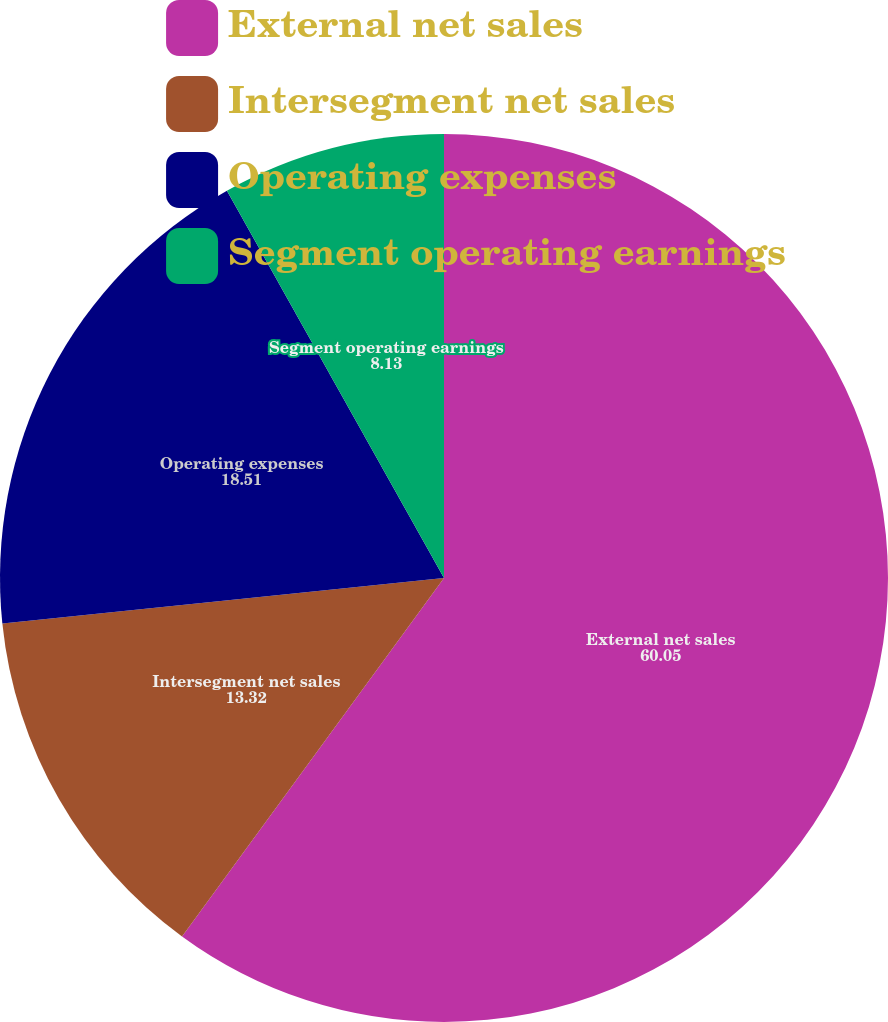Convert chart. <chart><loc_0><loc_0><loc_500><loc_500><pie_chart><fcel>External net sales<fcel>Intersegment net sales<fcel>Operating expenses<fcel>Segment operating earnings<nl><fcel>60.05%<fcel>13.32%<fcel>18.51%<fcel>8.13%<nl></chart> 